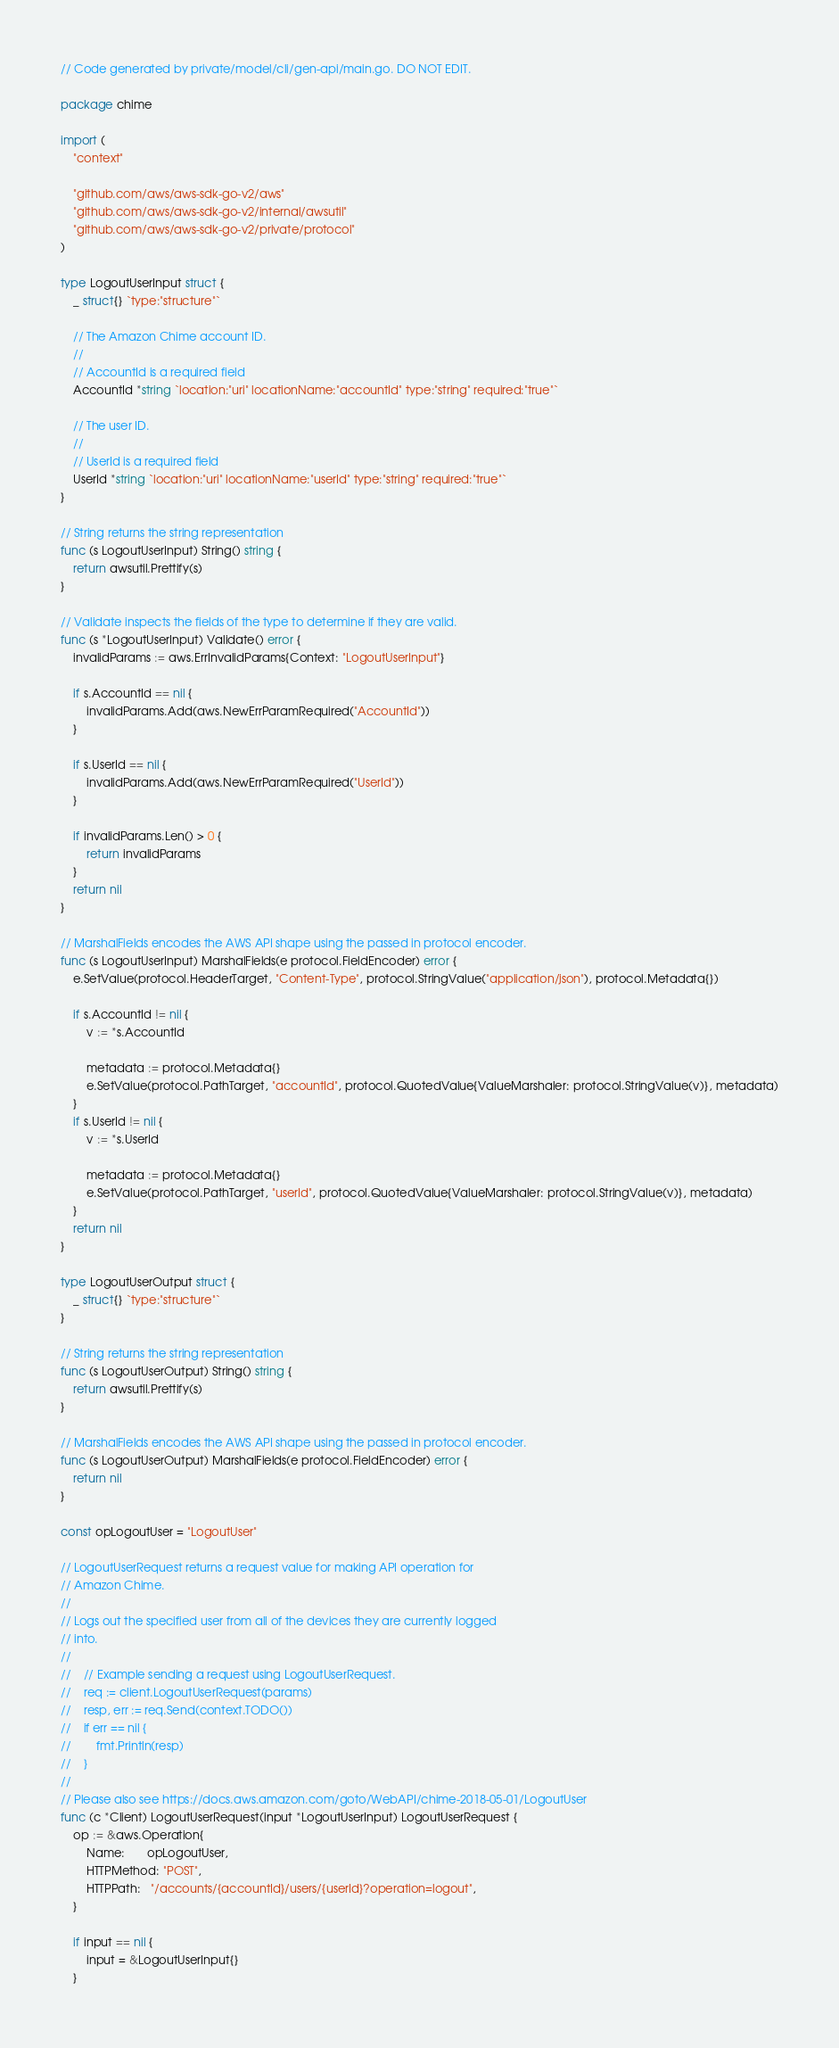Convert code to text. <code><loc_0><loc_0><loc_500><loc_500><_Go_>// Code generated by private/model/cli/gen-api/main.go. DO NOT EDIT.

package chime

import (
	"context"

	"github.com/aws/aws-sdk-go-v2/aws"
	"github.com/aws/aws-sdk-go-v2/internal/awsutil"
	"github.com/aws/aws-sdk-go-v2/private/protocol"
)

type LogoutUserInput struct {
	_ struct{} `type:"structure"`

	// The Amazon Chime account ID.
	//
	// AccountId is a required field
	AccountId *string `location:"uri" locationName:"accountId" type:"string" required:"true"`

	// The user ID.
	//
	// UserId is a required field
	UserId *string `location:"uri" locationName:"userId" type:"string" required:"true"`
}

// String returns the string representation
func (s LogoutUserInput) String() string {
	return awsutil.Prettify(s)
}

// Validate inspects the fields of the type to determine if they are valid.
func (s *LogoutUserInput) Validate() error {
	invalidParams := aws.ErrInvalidParams{Context: "LogoutUserInput"}

	if s.AccountId == nil {
		invalidParams.Add(aws.NewErrParamRequired("AccountId"))
	}

	if s.UserId == nil {
		invalidParams.Add(aws.NewErrParamRequired("UserId"))
	}

	if invalidParams.Len() > 0 {
		return invalidParams
	}
	return nil
}

// MarshalFields encodes the AWS API shape using the passed in protocol encoder.
func (s LogoutUserInput) MarshalFields(e protocol.FieldEncoder) error {
	e.SetValue(protocol.HeaderTarget, "Content-Type", protocol.StringValue("application/json"), protocol.Metadata{})

	if s.AccountId != nil {
		v := *s.AccountId

		metadata := protocol.Metadata{}
		e.SetValue(protocol.PathTarget, "accountId", protocol.QuotedValue{ValueMarshaler: protocol.StringValue(v)}, metadata)
	}
	if s.UserId != nil {
		v := *s.UserId

		metadata := protocol.Metadata{}
		e.SetValue(protocol.PathTarget, "userId", protocol.QuotedValue{ValueMarshaler: protocol.StringValue(v)}, metadata)
	}
	return nil
}

type LogoutUserOutput struct {
	_ struct{} `type:"structure"`
}

// String returns the string representation
func (s LogoutUserOutput) String() string {
	return awsutil.Prettify(s)
}

// MarshalFields encodes the AWS API shape using the passed in protocol encoder.
func (s LogoutUserOutput) MarshalFields(e protocol.FieldEncoder) error {
	return nil
}

const opLogoutUser = "LogoutUser"

// LogoutUserRequest returns a request value for making API operation for
// Amazon Chime.
//
// Logs out the specified user from all of the devices they are currently logged
// into.
//
//    // Example sending a request using LogoutUserRequest.
//    req := client.LogoutUserRequest(params)
//    resp, err := req.Send(context.TODO())
//    if err == nil {
//        fmt.Println(resp)
//    }
//
// Please also see https://docs.aws.amazon.com/goto/WebAPI/chime-2018-05-01/LogoutUser
func (c *Client) LogoutUserRequest(input *LogoutUserInput) LogoutUserRequest {
	op := &aws.Operation{
		Name:       opLogoutUser,
		HTTPMethod: "POST",
		HTTPPath:   "/accounts/{accountId}/users/{userId}?operation=logout",
	}

	if input == nil {
		input = &LogoutUserInput{}
	}
</code> 